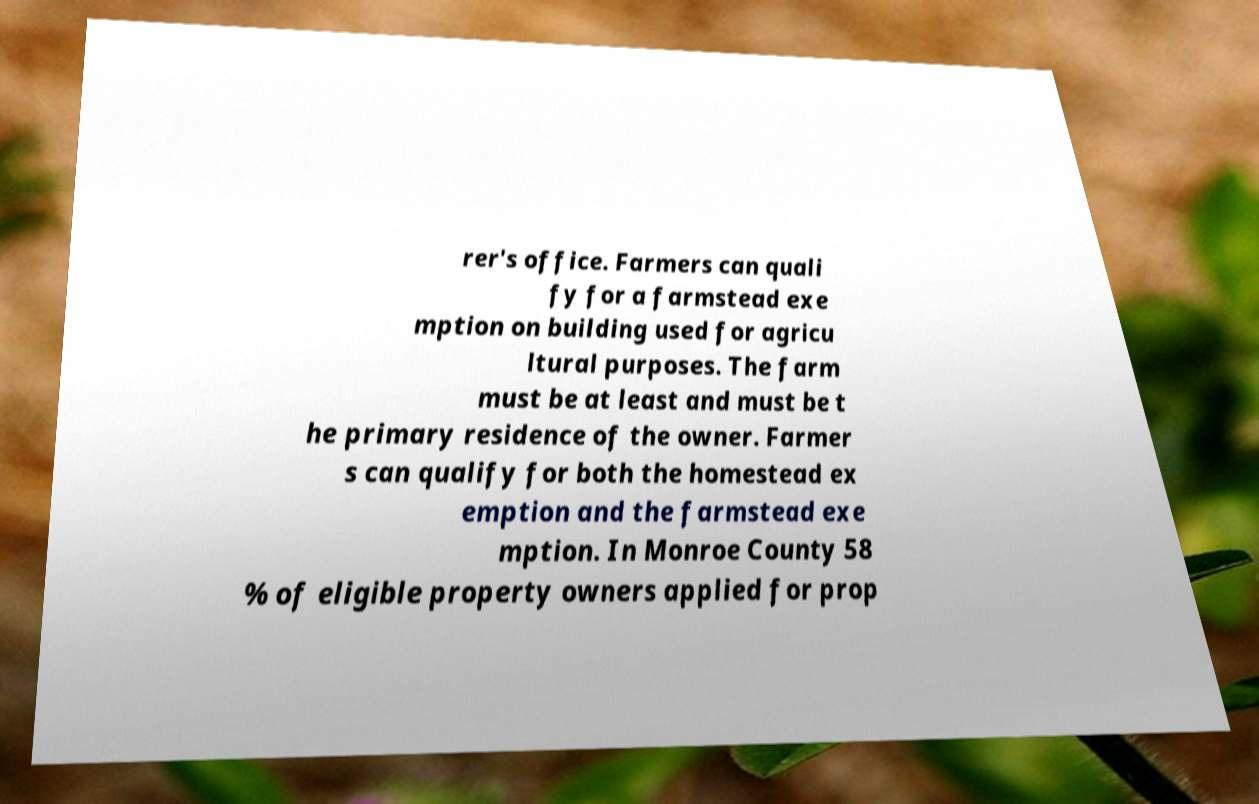I need the written content from this picture converted into text. Can you do that? rer's office. Farmers can quali fy for a farmstead exe mption on building used for agricu ltural purposes. The farm must be at least and must be t he primary residence of the owner. Farmer s can qualify for both the homestead ex emption and the farmstead exe mption. In Monroe County 58 % of eligible property owners applied for prop 